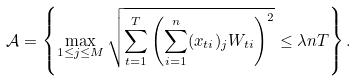Convert formula to latex. <formula><loc_0><loc_0><loc_500><loc_500>\mathcal { A } = \left \{ \max _ { 1 \leq j \leq M } \sqrt { \sum _ { t = 1 } ^ { T } \left ( \sum _ { i = 1 } ^ { n } ( x _ { t i } ) _ { j } W _ { t i } \right ) ^ { 2 } } \leq \lambda n T \right \} .</formula> 